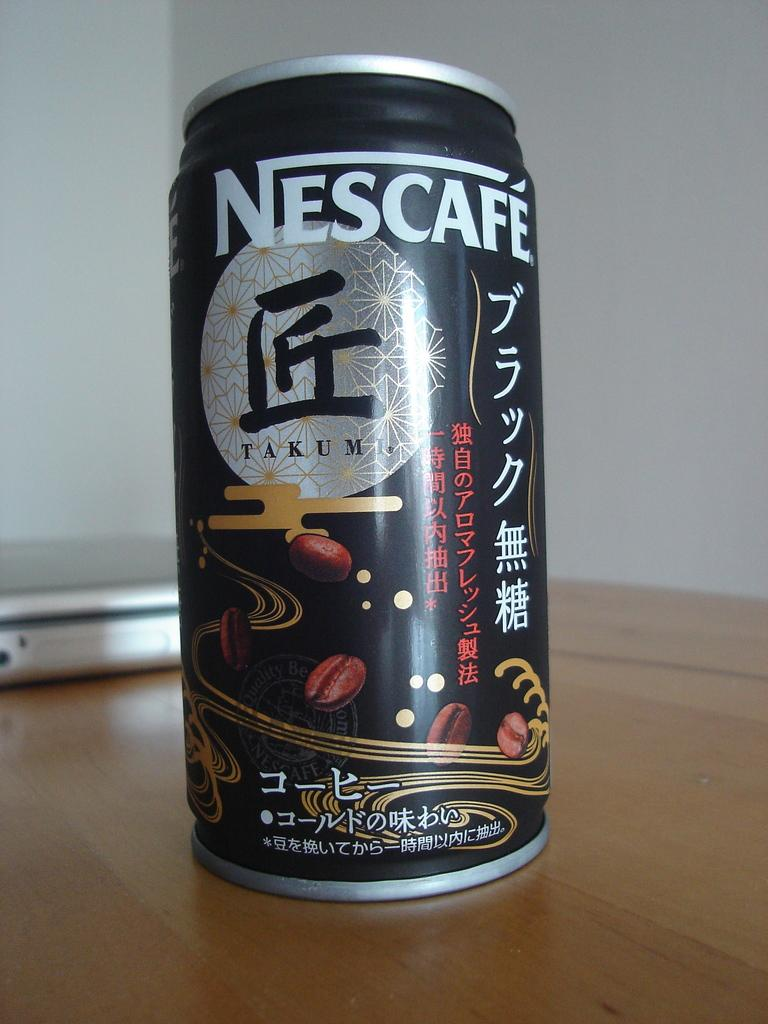<image>
Provide a brief description of the given image. A can of Nescafe Takumi is sitting on a table. 